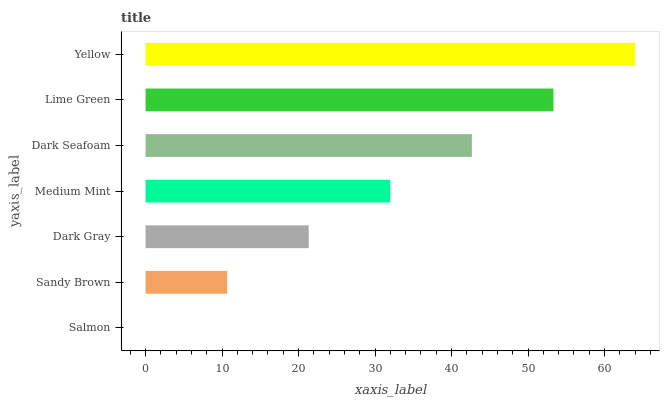Is Salmon the minimum?
Answer yes or no. Yes. Is Yellow the maximum?
Answer yes or no. Yes. Is Sandy Brown the minimum?
Answer yes or no. No. Is Sandy Brown the maximum?
Answer yes or no. No. Is Sandy Brown greater than Salmon?
Answer yes or no. Yes. Is Salmon less than Sandy Brown?
Answer yes or no. Yes. Is Salmon greater than Sandy Brown?
Answer yes or no. No. Is Sandy Brown less than Salmon?
Answer yes or no. No. Is Medium Mint the high median?
Answer yes or no. Yes. Is Medium Mint the low median?
Answer yes or no. Yes. Is Salmon the high median?
Answer yes or no. No. Is Sandy Brown the low median?
Answer yes or no. No. 